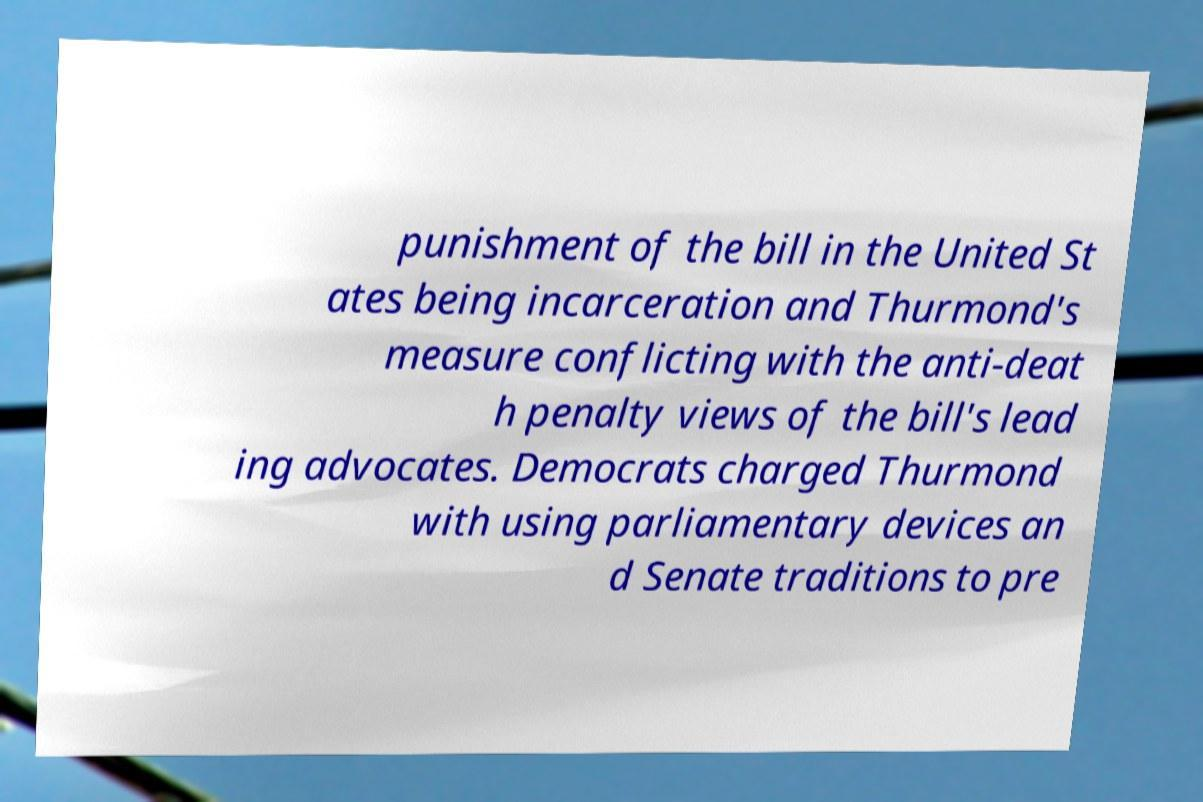Could you extract and type out the text from this image? punishment of the bill in the United St ates being incarceration and Thurmond's measure conflicting with the anti-deat h penalty views of the bill's lead ing advocates. Democrats charged Thurmond with using parliamentary devices an d Senate traditions to pre 